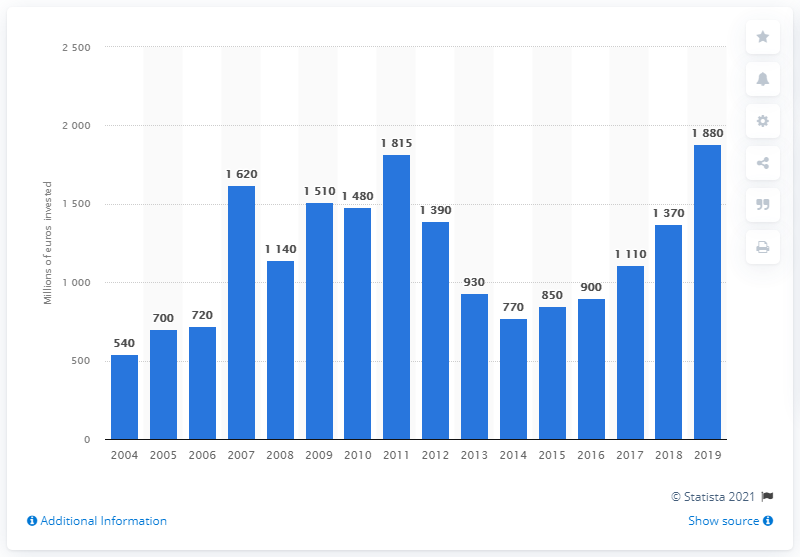Mention a couple of crucial points in this snapshot. According to data from 2019, a significant amount of funds was invested in airport infrastructure in Germany. In 2011, the total amount of investments in airport infrastructure was 1,815. 